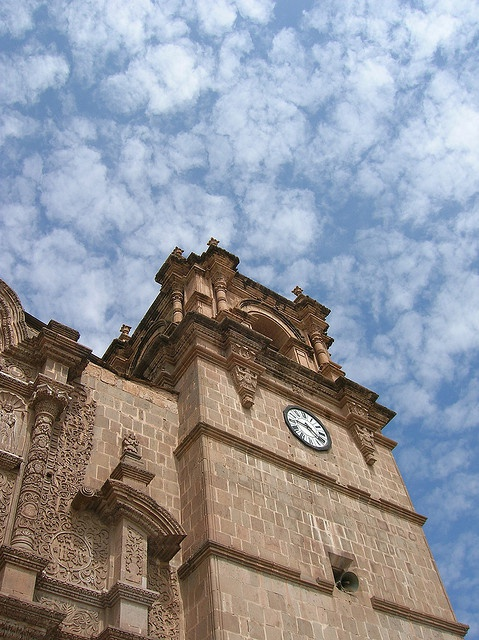Describe the objects in this image and their specific colors. I can see a clock in darkgray, white, gray, and black tones in this image. 